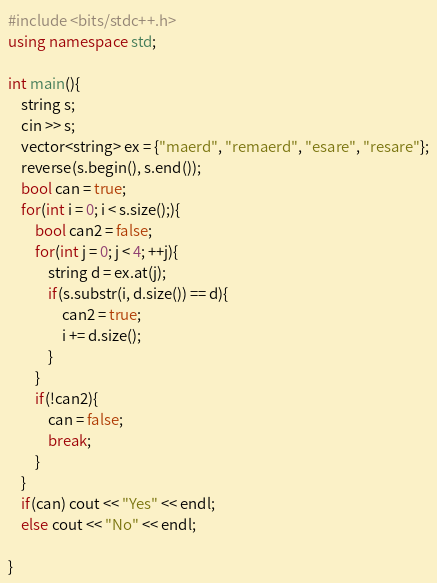Convert code to text. <code><loc_0><loc_0><loc_500><loc_500><_C++_>#include <bits/stdc++.h>
using namespace std;

int main(){
    string s;
    cin >> s;
    vector<string> ex = {"maerd", "remaerd", "esare", "resare"};
    reverse(s.begin(), s.end());
    bool can = true;
    for(int i = 0; i < s.size();){
        bool can2 = false;
        for(int j = 0; j < 4; ++j){
            string d = ex.at(j);
            if(s.substr(i, d.size()) == d){
                can2 = true;
                i += d.size();
            }
        }
        if(!can2){
            can = false;
            break;
        }
    }
    if(can) cout << "Yes" << endl;
    else cout << "No" << endl;

}</code> 